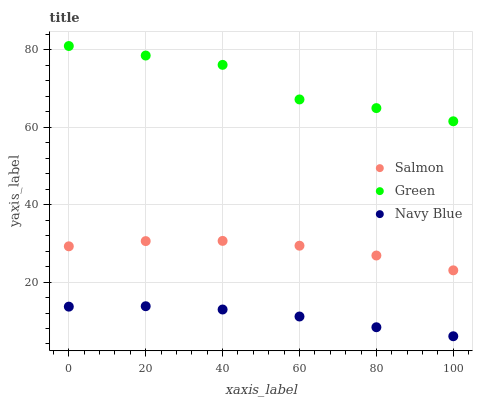Does Navy Blue have the minimum area under the curve?
Answer yes or no. Yes. Does Green have the maximum area under the curve?
Answer yes or no. Yes. Does Salmon have the minimum area under the curve?
Answer yes or no. No. Does Salmon have the maximum area under the curve?
Answer yes or no. No. Is Navy Blue the smoothest?
Answer yes or no. Yes. Is Green the roughest?
Answer yes or no. Yes. Is Salmon the smoothest?
Answer yes or no. No. Is Salmon the roughest?
Answer yes or no. No. Does Navy Blue have the lowest value?
Answer yes or no. Yes. Does Salmon have the lowest value?
Answer yes or no. No. Does Green have the highest value?
Answer yes or no. Yes. Does Salmon have the highest value?
Answer yes or no. No. Is Salmon less than Green?
Answer yes or no. Yes. Is Green greater than Salmon?
Answer yes or no. Yes. Does Salmon intersect Green?
Answer yes or no. No. 